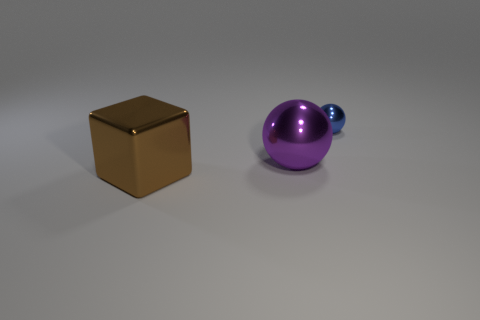Add 2 gray blocks. How many objects exist? 5 Subtract all spheres. How many objects are left? 1 Subtract 0 cyan cylinders. How many objects are left? 3 Subtract all small red rubber cubes. Subtract all shiny things. How many objects are left? 0 Add 3 purple balls. How many purple balls are left? 4 Add 2 large brown shiny things. How many large brown shiny things exist? 3 